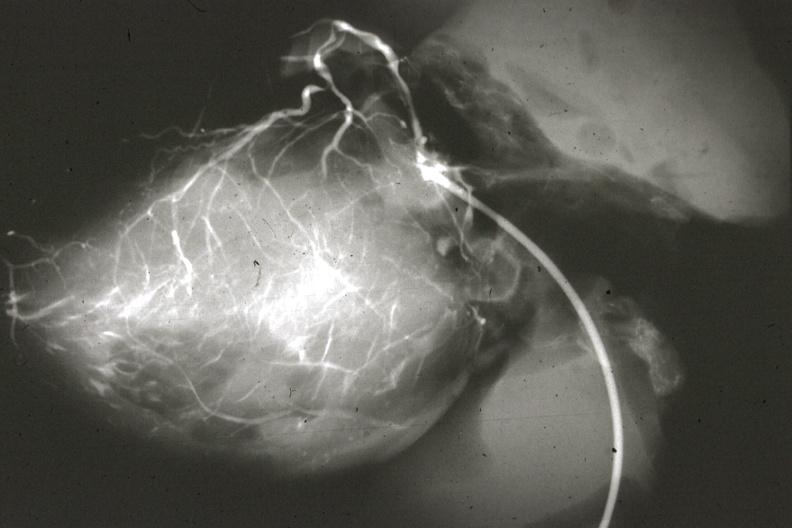what does this image show?
Answer the question using a single word or phrase. Angiogram postmortafter switch of left coronary to aorta 